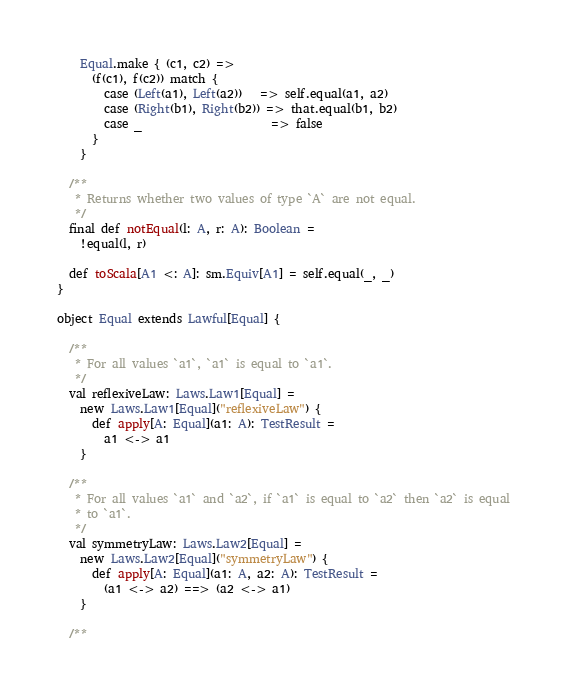Convert code to text. <code><loc_0><loc_0><loc_500><loc_500><_Scala_>    Equal.make { (c1, c2) =>
      (f(c1), f(c2)) match {
        case (Left(a1), Left(a2))   => self.equal(a1, a2)
        case (Right(b1), Right(b2)) => that.equal(b1, b2)
        case _                      => false
      }
    }

  /**
   * Returns whether two values of type `A` are not equal.
   */
  final def notEqual(l: A, r: A): Boolean =
    !equal(l, r)

  def toScala[A1 <: A]: sm.Equiv[A1] = self.equal(_, _)
}

object Equal extends Lawful[Equal] {

  /**
   * For all values `a1`, `a1` is equal to `a1`.
   */
  val reflexiveLaw: Laws.Law1[Equal] =
    new Laws.Law1[Equal]("reflexiveLaw") {
      def apply[A: Equal](a1: A): TestResult =
        a1 <-> a1
    }

  /**
   * For all values `a1` and `a2`, if `a1` is equal to `a2` then `a2` is equal
   * to `a1`.
   */
  val symmetryLaw: Laws.Law2[Equal] =
    new Laws.Law2[Equal]("symmetryLaw") {
      def apply[A: Equal](a1: A, a2: A): TestResult =
        (a1 <-> a2) ==> (a2 <-> a1)
    }

  /**</code> 